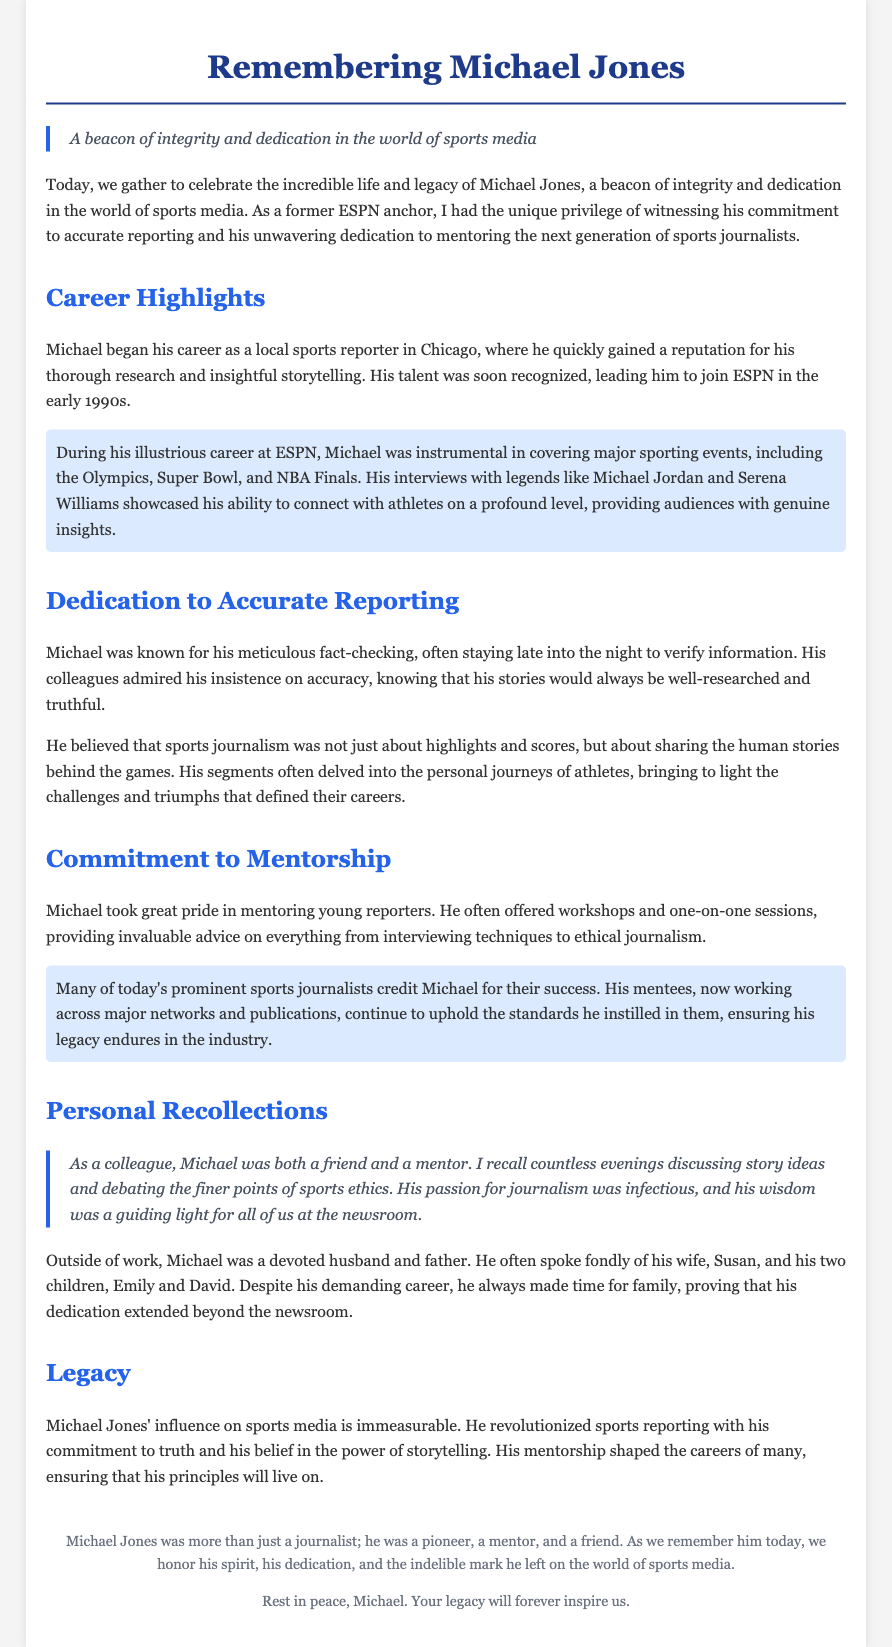What was Michael Jones known for? Michael Jones was known for his meticulous fact-checking and commitment to accurate reporting in sports journalism.
Answer: Accurate reporting Which major sporting events did Michael cover? During his career, Michael was instrumental in covering events including the Olympics, Super Bowl, and NBA Finals.
Answer: Olympics, Super Bowl, and NBA Finals What was Michael's role in mentoring young reporters? Michael offered workshops and one-on-one sessions to provide advice on various aspects of journalism.
Answer: Mentorship Who did Michael often speak fondly of? Michael often spoke fondly of his wife, Susan, and his two children, Emily and David.
Answer: Susan, Emily, and David How did Michael influence other sports journalists? Many of today's prominent sports journalists credit Michael for their success and uphold the standards he instilled in them.
Answer: Success and mentoring What did Michael believe sports journalism should convey? He believed sports journalism was about sharing the human stories behind the games, not just highlights and scores.
Answer: Human stories What is the essence of Michael’s legacy? Michael's legacy is characterized by his commitment to truth and the power of storytelling in sports media.
Answer: Commitment to truth What phrase describes Michael Jones in the quote at the beginning? The quote calls him "a beacon of integrity and dedication in the world of sports media."
Answer: Beacon of integrity How did Michael balance his demanding career and personal life? Despite his demanding career, he always made time for family.
Answer: Family time 